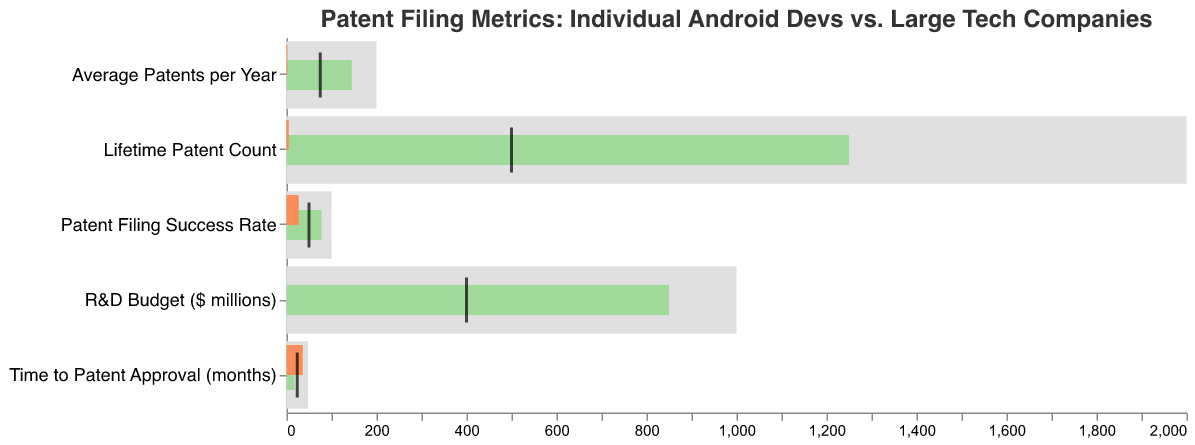What is the difference in the Patent Filing Success Rate between Individual Android Devs and Large Tech Companies? The Patent Filing Success Rate for Individual Android Devs is 27, and for Large Tech Companies, it is 78. The difference is calculated by subtracting 27 from 78.
Answer: 51 Which category has the smallest value for Individual Android Devs? By examining the values in the chart, we see that the R&D Budget ($ millions) is the smallest for Individual Android Devs, with a value of 0.05.
Answer: R&D Budget ($ millions) How many months does it typically take for a patent approval for Individual Android Devs compared to Large Tech Companies? The Time to Patent Approval is 36 months for Individual Android Devs and 18 months for Large Tech Companies. This data point is directly available from the figure.
Answer: 36 months (Individual Android Devs), 18 months (Large Tech Companies) How much more is the Lifetime Patent Count for Large Tech Companies compared to Individual Android Devs? The Lifetime Patent Count for Large Tech Companies is 1250, and for Individual Android Devs, it is 5. The difference is calculated by subtracting 5 from 1250.
Answer: 1245 What is the median value between the R&D Budget of Individual Android Devs and Large Tech Companies, and how does it compare to the comparative measure? The R&D Budget for Individual Android Devs is 0.05, and for Large Tech Companies, it's 850. The median value is the average of these two, which can be calculated as (0.05 + 850) / 2 = 425.025, which is higher than the comparative measure of 400.
Answer: 425.025, higher Which Category shows the highest comparative measure? The comparative measures are clearly marked as ticks. By comparing these measures, we see that Lifetime Patent Count, at 500, has the highest value.
Answer: Lifetime Patent Count In which category do Individual Android Devs have the closest value to the comparative measure, compared to other categories? Looking at the Individual Android Devs' values and their comparative measures across categories, Patent Filing Success Rate (27 compared to 50) has the smallest difference of 23.
Answer: Patent Filing Success Rate How many more Average Patents per Year do Large Tech Companies have compared to Individual Android Devs? Large Tech Companies have an Average Patents per Year of 145, while Individual Android Devs have 2. The difference is calculated by subtracting 2 from 145.
Answer: 143 